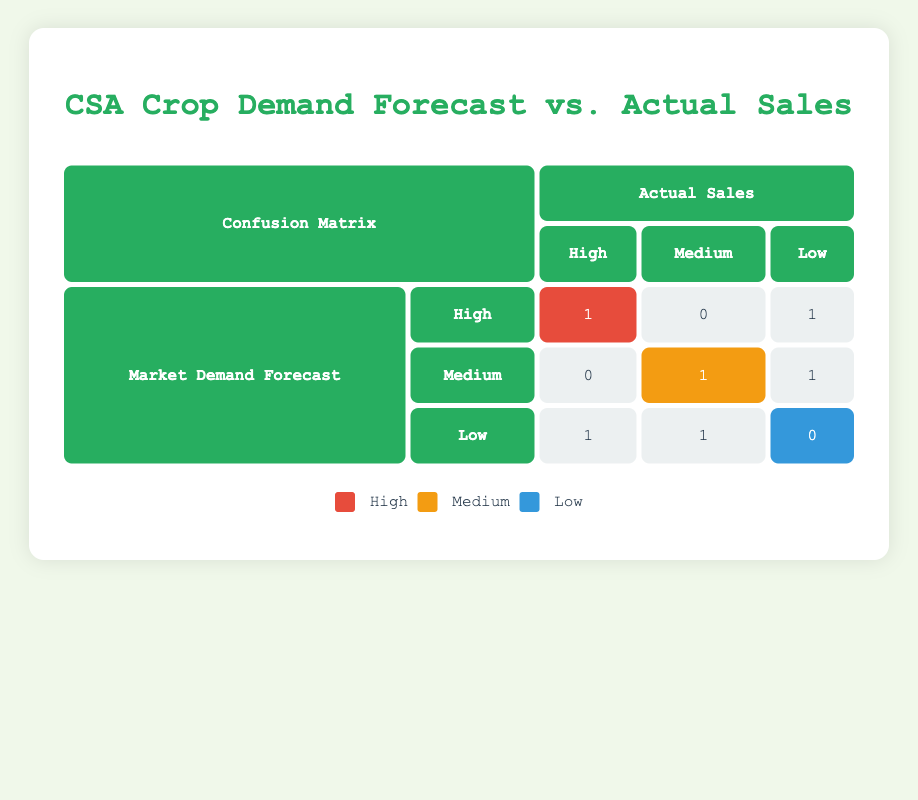What is the total number of crops forecasted as High demand? In the table, we look at the "Market Demand Forecast" row labeled "High." There are 3 entries that fall under that classification—1 with actual sales of High, 0 with Medium, and 1 with Low. Therefore, total crops forecasted as High demand is 3.
Answer: 3 How many crops actually sold were classified as Low? Looking under the "Actual Sales" column labeled "Low," we find 3 entries: 1 from High forecast, 1 from Medium forecast, and 1 from Low forecast. Thus, the total number of crops that had actual sales classified as Low is 3.
Answer: 3 Did any crops have a High demand forecast but sold Low? Checking the "High" row under "Market Demand Forecast" and the "Low" column under "Actual Sales," we see that there is indeed 1 crop with this classification—Tomatoes. Hence, the answer is yes.
Answer: Yes What is the difference between the number of crops forecasted as Medium and those with actual sales as Medium? We can count the crops forecasted as Medium, which totals 3: 0 with High sales, 1 with Medium sales, and 1 with Low sales. For actual sales classified as Medium, there is 1 crop. Therefore, the difference is 3 - 1 = 2.
Answer: 2 Which crop had a High demand forecast and actual sales matching that forecast? In the table, looking under the "High" row for "Market Demand Forecast" and the corresponding column for "High" sales, we see there is 1 crop—Carrots. So, the crop that meets these criteria is Carrots.
Answer: Carrots How many crops had a Medium market demand forecast and actually sold Low? For the "Medium" forecast row, there is 1 entry for Low sales. Therefore, the total crops that fall into this category is 1.
Answer: 1 Did any crops exceed their forecast by selling High when forecasted as Low? Checking the "Low" forecast row, we find that Bell Peppers had actual sales classified as High. Therefore, there was an occurrence of exceeding the forecast.
Answer: Yes What crops fell under the category of Low demand forecast yet sold Medium? For the "Low" row under the "Market Demand Forecast" column, we notice that only 1 crop, Spinach, had actual sales categorized as Medium, which means it didn't match its forecast.
Answer: Spinach 